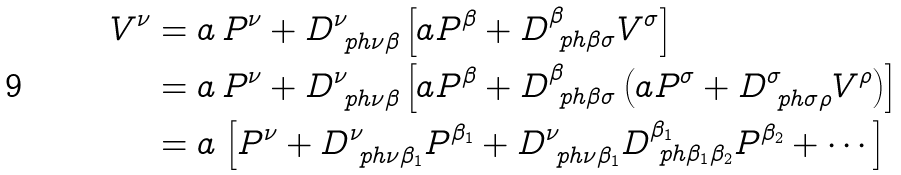<formula> <loc_0><loc_0><loc_500><loc_500>V ^ { \nu } & = a \, P ^ { \nu } + D ^ { \nu } _ { \ p h { \nu } \beta } \left [ a P ^ { \beta } + D ^ { \beta } _ { \ p h { \beta } \sigma } V ^ { \sigma } \right ] \\ & = a \, P ^ { \nu } + D ^ { \nu } _ { \ p h { \nu } \beta } \left [ a P ^ { \beta } + D ^ { \beta } _ { \ p h { \beta } \sigma } \left ( a P ^ { \sigma } + D ^ { \sigma } _ { \ p h { \sigma } \rho } V ^ { \rho } \right ) \right ] \\ & = a \, \left [ P ^ { \nu } + D ^ { \nu } _ { \ p h { \nu } \beta _ { 1 } } P ^ { \beta _ { 1 } } + D ^ { \nu } _ { \ p h { \nu } \beta _ { 1 } } D ^ { \beta _ { 1 } } _ { \ p h { \beta _ { 1 } } \beta _ { 2 } } P ^ { \beta _ { 2 } } + \cdots \right ]</formula> 